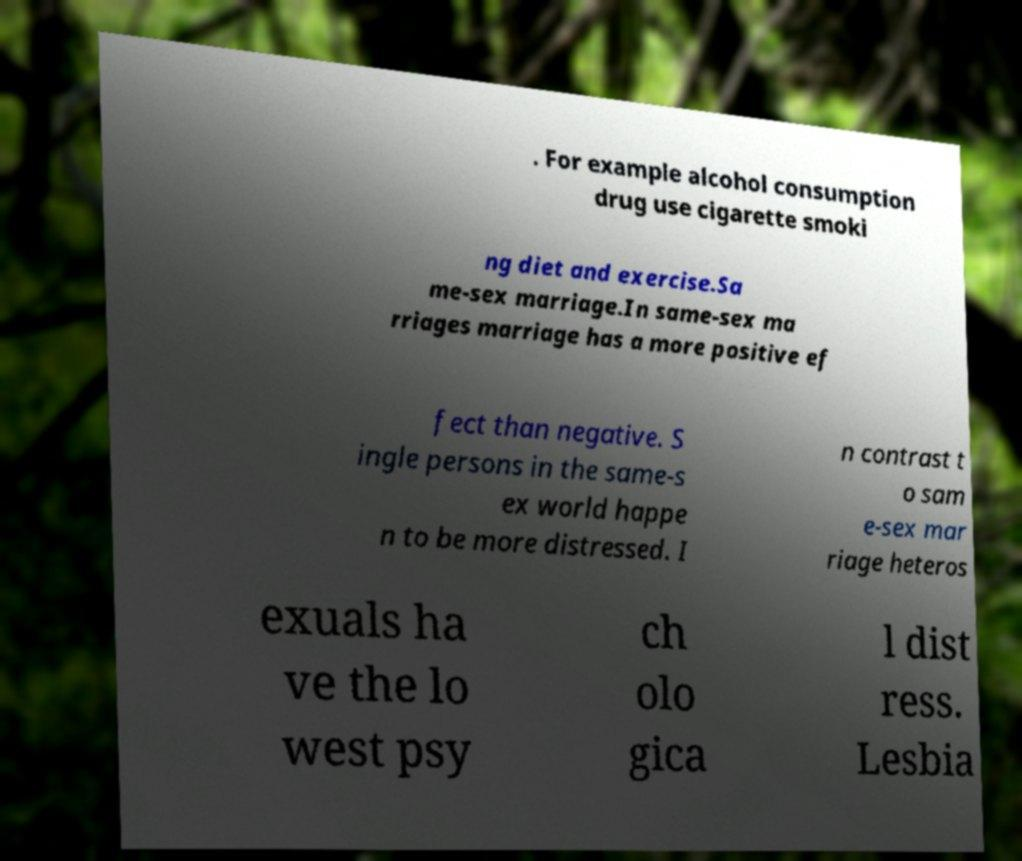Please read and relay the text visible in this image. What does it say? . For example alcohol consumption drug use cigarette smoki ng diet and exercise.Sa me-sex marriage.In same-sex ma rriages marriage has a more positive ef fect than negative. S ingle persons in the same-s ex world happe n to be more distressed. I n contrast t o sam e-sex mar riage heteros exuals ha ve the lo west psy ch olo gica l dist ress. Lesbia 